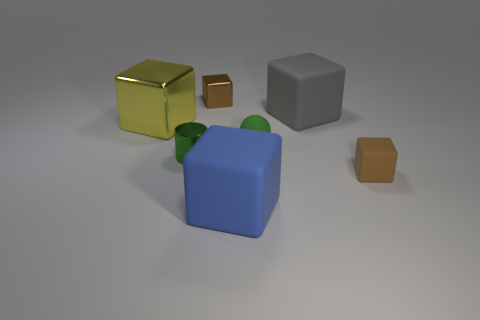Is the number of blocks behind the tiny green cylinder less than the number of gray objects?
Offer a very short reply. No. Do the brown object that is behind the big yellow metallic object and the small rubber thing that is left of the tiny matte block have the same shape?
Your answer should be very brief. No. How many things are either brown blocks in front of the small brown shiny cube or big yellow rubber balls?
Provide a succinct answer. 1. What is the material of the ball that is the same color as the tiny cylinder?
Your answer should be very brief. Rubber. Is there a cube behind the tiny green rubber sphere that is behind the brown block in front of the gray cube?
Offer a terse response. Yes. Are there fewer cylinders that are behind the rubber sphere than big things that are left of the green shiny cylinder?
Make the answer very short. Yes. What is the color of the ball that is made of the same material as the large gray block?
Your answer should be compact. Green. There is a big matte block that is in front of the large block to the left of the tiny metal cylinder; what color is it?
Provide a short and direct response. Blue. Are there any large balls that have the same color as the metal cylinder?
Make the answer very short. No. What shape is the green matte thing that is the same size as the green cylinder?
Give a very brief answer. Sphere. 